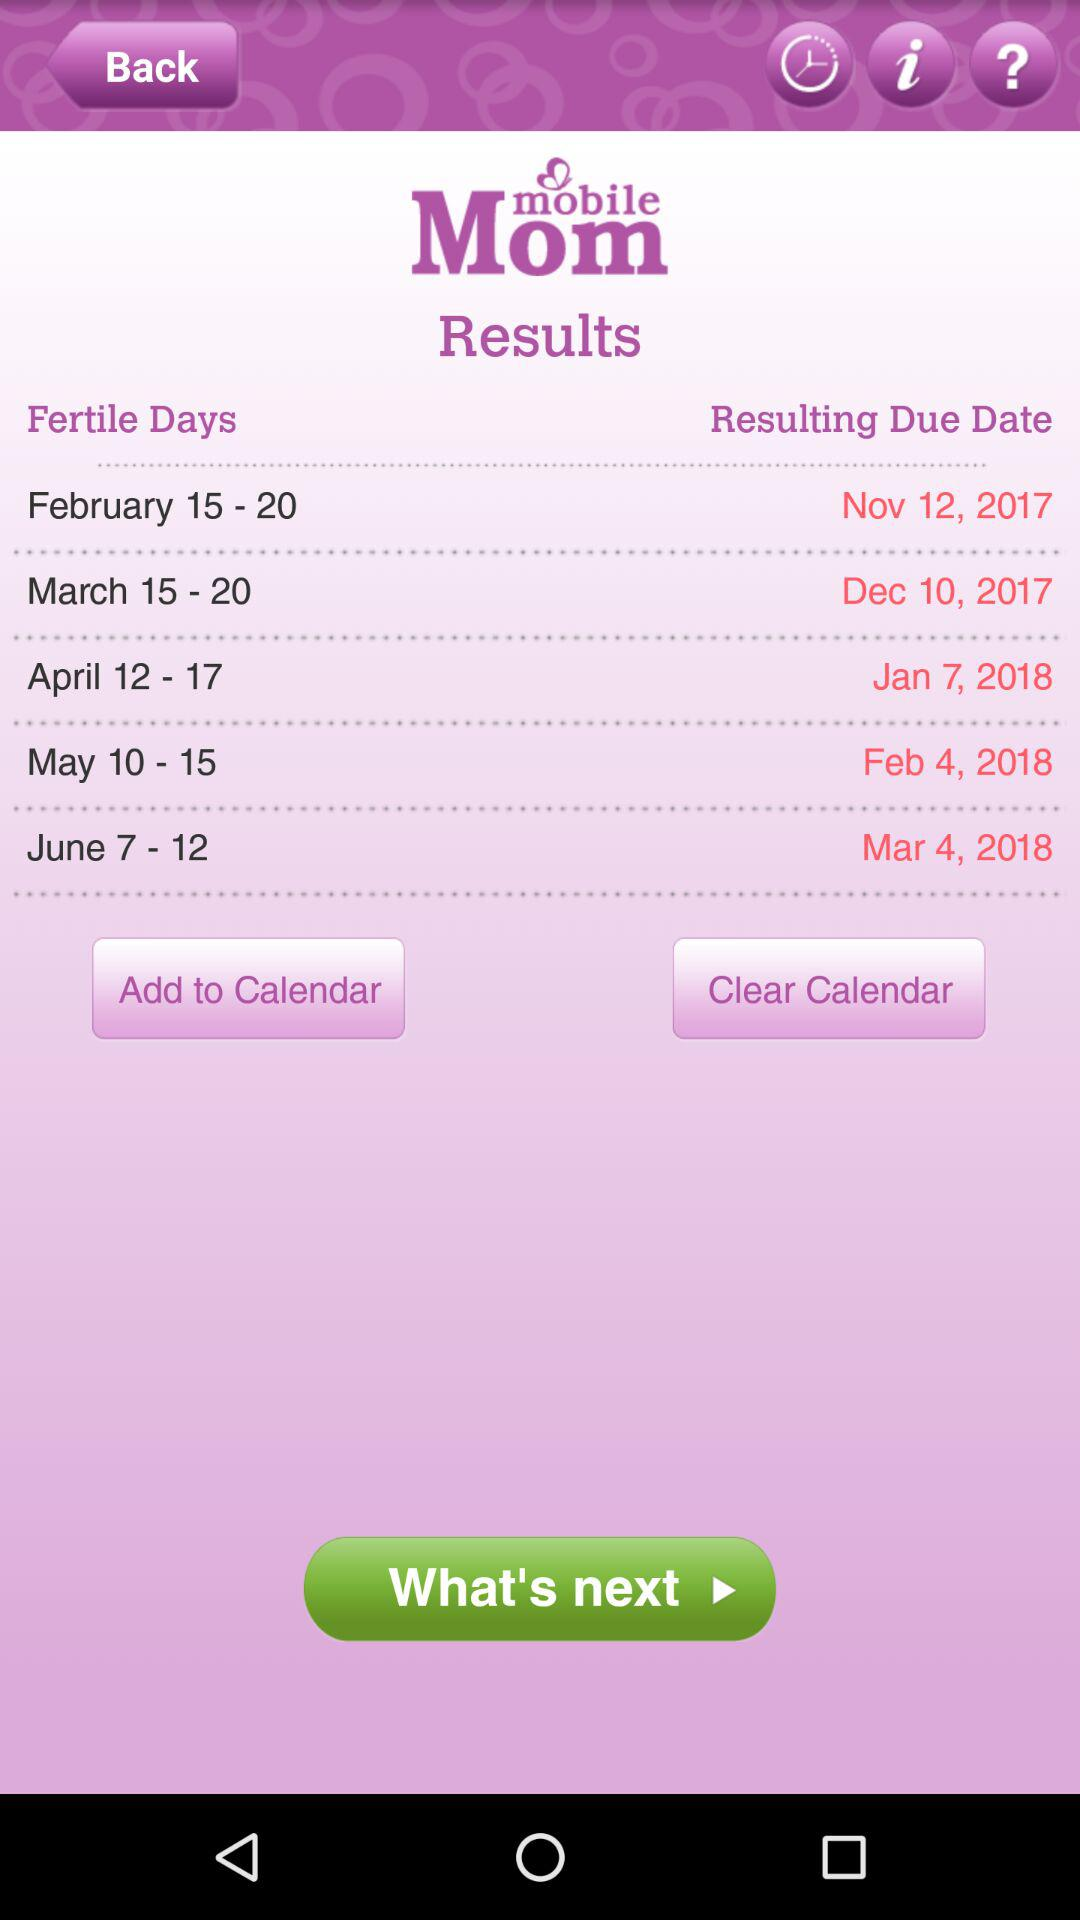What is the resulting due date if the fertile days are from February 15 to 20? The resulting due date is November 12, 2017. 